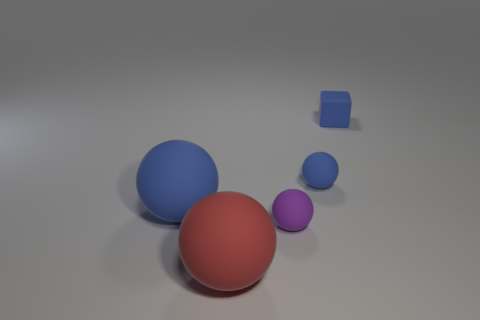Subtract all green spheres. Subtract all red blocks. How many spheres are left? 4 Add 5 blue balls. How many objects exist? 10 Subtract all spheres. How many objects are left? 1 Subtract 0 red cylinders. How many objects are left? 5 Subtract all big blue spheres. Subtract all large red balls. How many objects are left? 3 Add 1 large blue things. How many large blue things are left? 2 Add 5 red matte objects. How many red matte objects exist? 6 